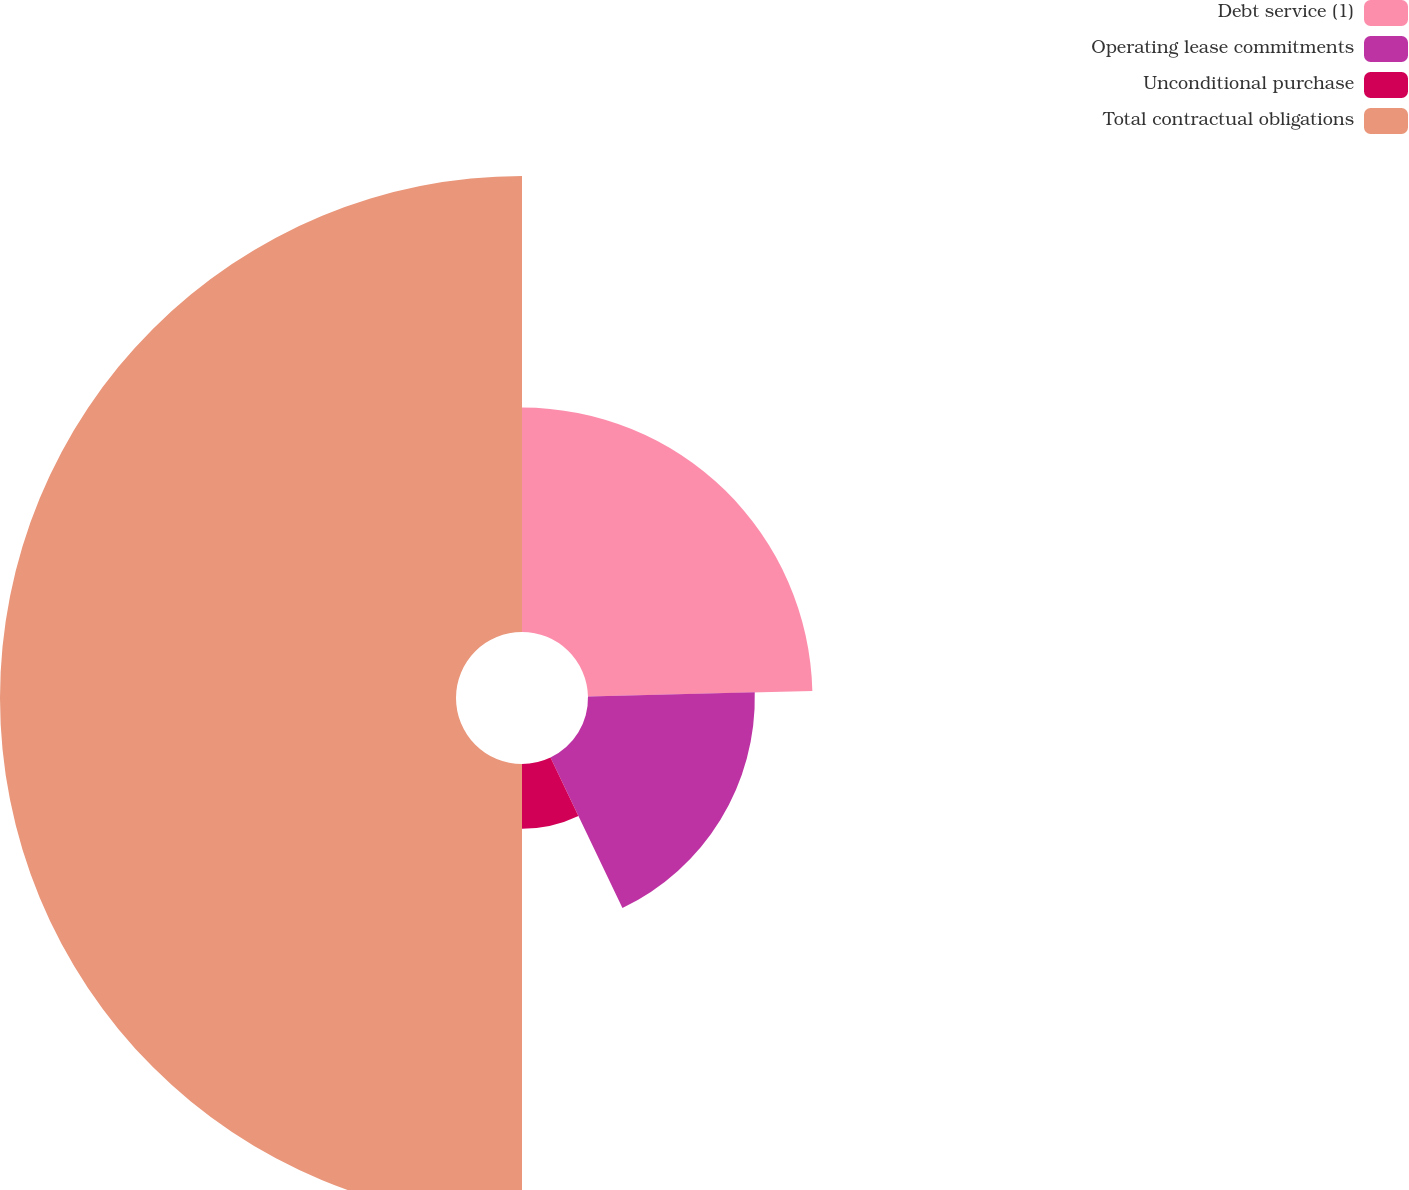Convert chart. <chart><loc_0><loc_0><loc_500><loc_500><pie_chart><fcel>Debt service (1)<fcel>Operating lease commitments<fcel>Unconditional purchase<fcel>Total contractual obligations<nl><fcel>24.61%<fcel>18.29%<fcel>7.1%<fcel>50.0%<nl></chart> 